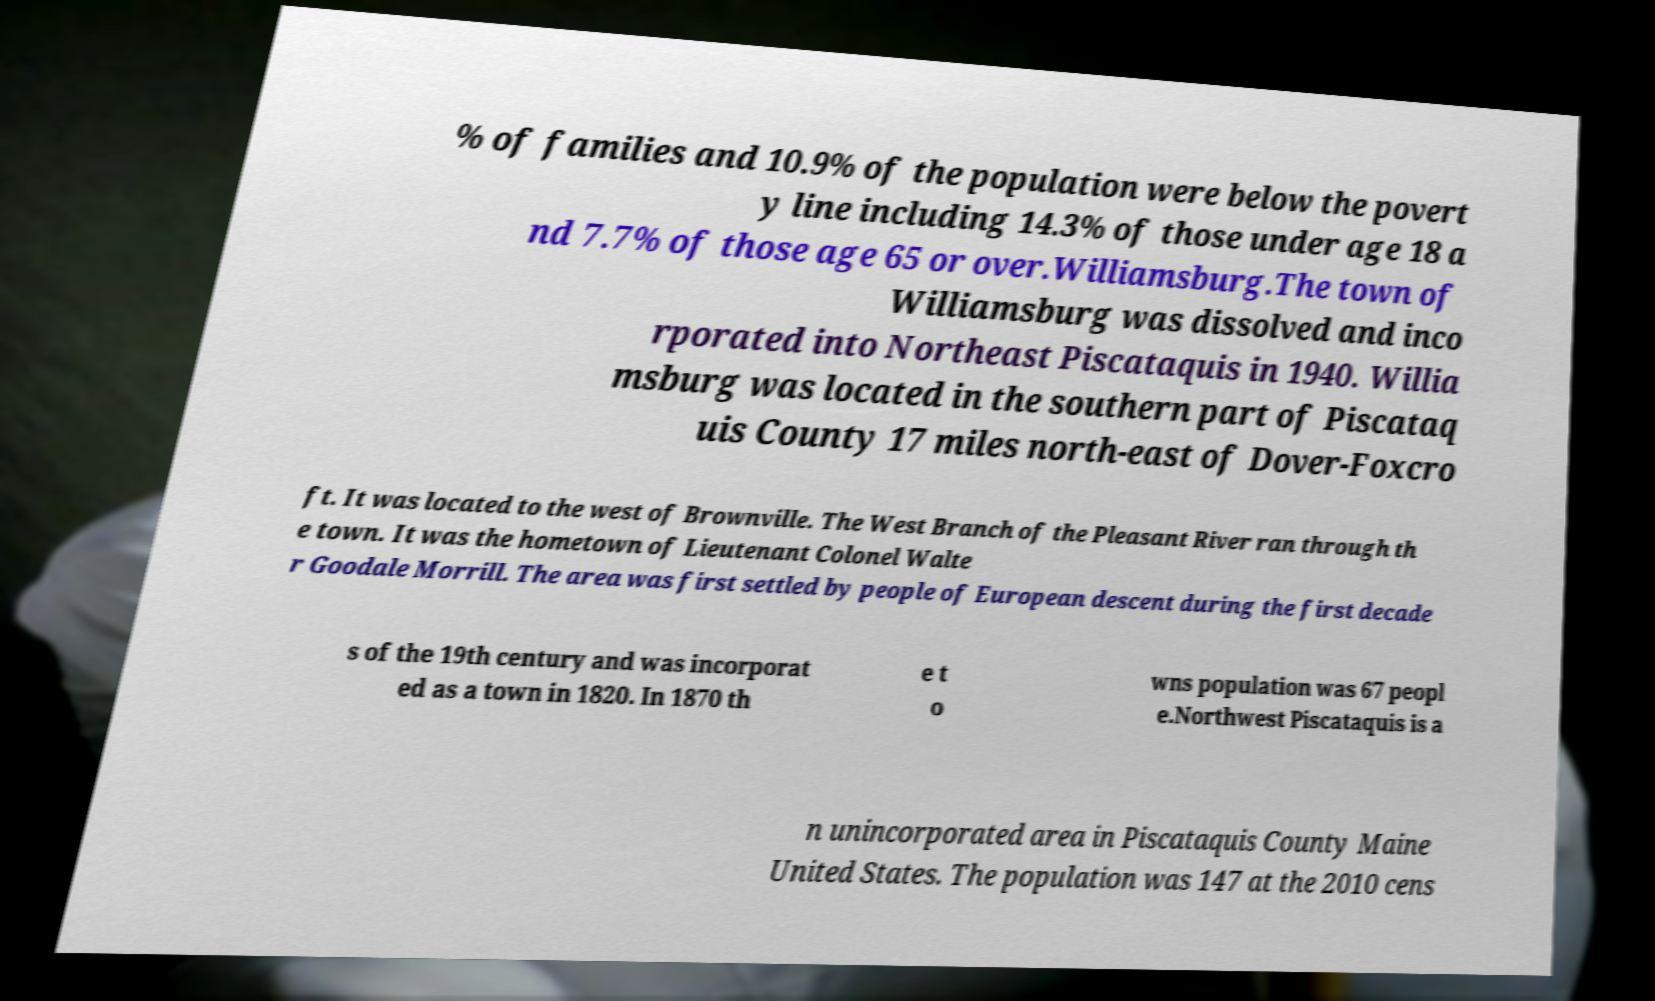Can you accurately transcribe the text from the provided image for me? % of families and 10.9% of the population were below the povert y line including 14.3% of those under age 18 a nd 7.7% of those age 65 or over.Williamsburg.The town of Williamsburg was dissolved and inco rporated into Northeast Piscataquis in 1940. Willia msburg was located in the southern part of Piscataq uis County 17 miles north-east of Dover-Foxcro ft. It was located to the west of Brownville. The West Branch of the Pleasant River ran through th e town. It was the hometown of Lieutenant Colonel Walte r Goodale Morrill. The area was first settled by people of European descent during the first decade s of the 19th century and was incorporat ed as a town in 1820. In 1870 th e t o wns population was 67 peopl e.Northwest Piscataquis is a n unincorporated area in Piscataquis County Maine United States. The population was 147 at the 2010 cens 